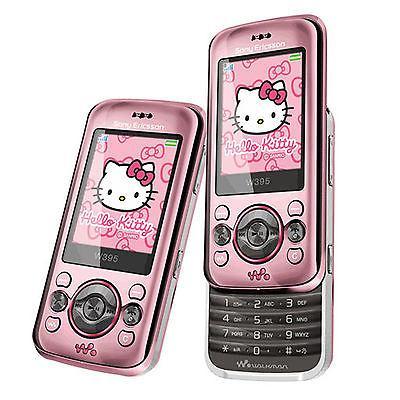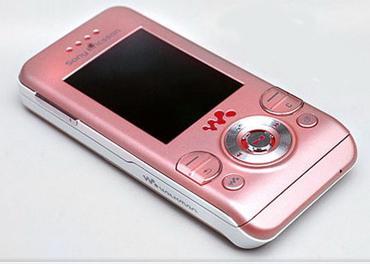The first image is the image on the left, the second image is the image on the right. Evaluate the accuracy of this statement regarding the images: "The screen of one of the phones is off.". Is it true? Answer yes or no. Yes. The first image is the image on the left, the second image is the image on the right. Given the left and right images, does the statement "Hello Kitty is on at least one of the phones." hold true? Answer yes or no. Yes. 